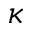Convert formula to latex. <formula><loc_0><loc_0><loc_500><loc_500>\kappa</formula> 